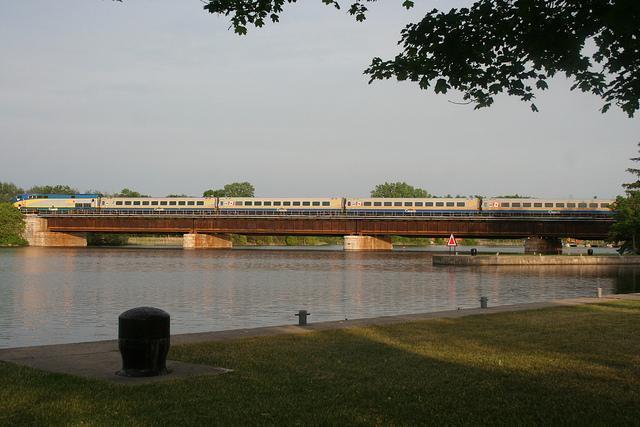How many cars does the train have?
Give a very brief answer. 4. How many pillars support the bridge?
Give a very brief answer. 4. 